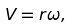Convert formula to latex. <formula><loc_0><loc_0><loc_500><loc_500>V = r \omega ,</formula> 